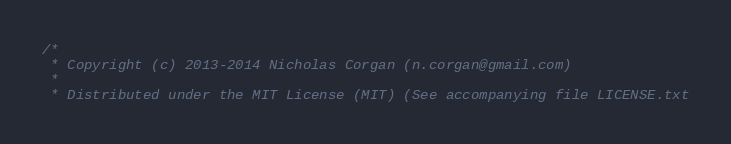<code> <loc_0><loc_0><loc_500><loc_500><_C++_>/*
 * Copyright (c) 2013-2014 Nicholas Corgan (n.corgan@gmail.com)
 *
 * Distributed under the MIT License (MIT) (See accompanying file LICENSE.txt</code> 